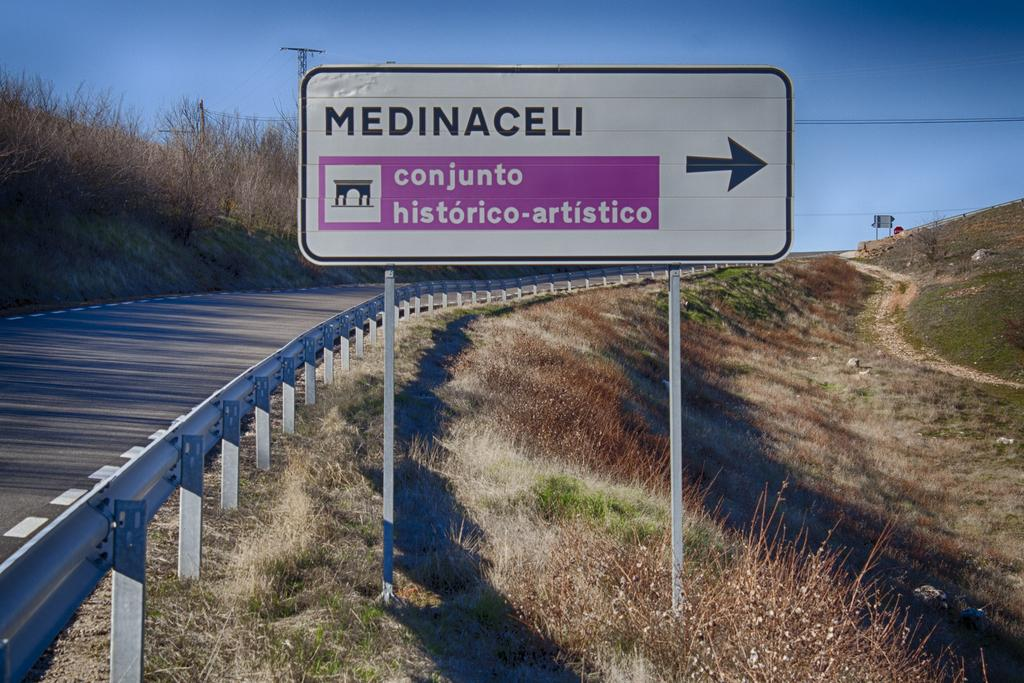<image>
Create a compact narrative representing the image presented. A sign on the side of the road points towards Medinaceli 